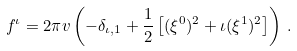Convert formula to latex. <formula><loc_0><loc_0><loc_500><loc_500>f ^ { \iota } = 2 \pi v \left ( - \delta _ { \iota , 1 } + \frac { 1 } { 2 } \left [ ( \xi ^ { 0 } ) ^ { 2 } + \iota ( \xi ^ { 1 } ) ^ { 2 } \right ] \right ) \, .</formula> 